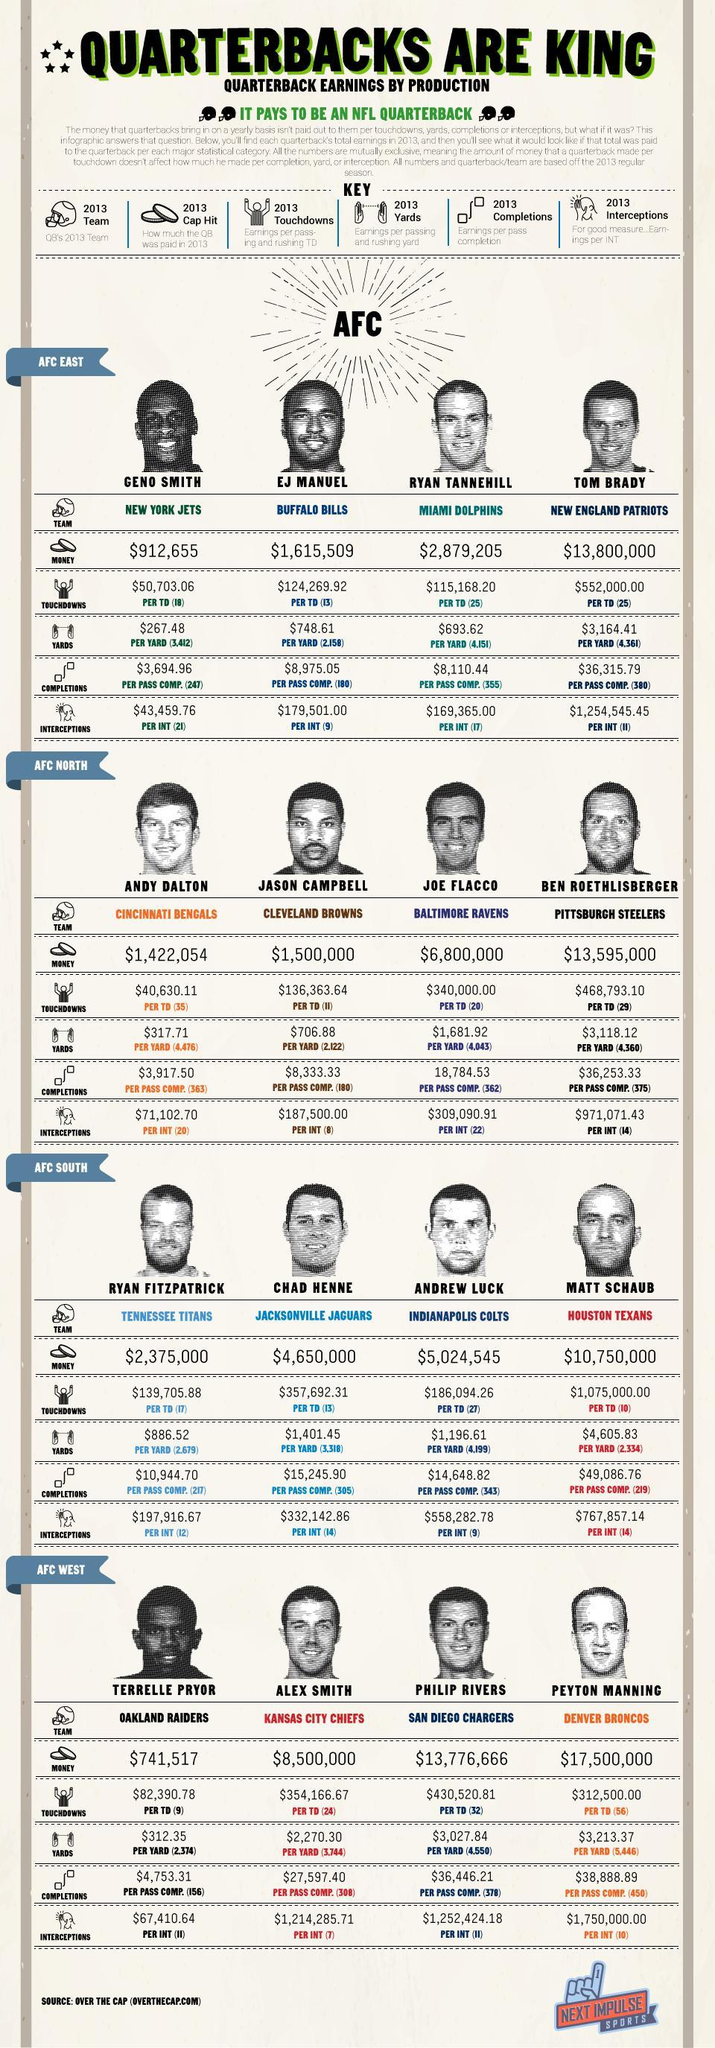How many teams are in the AFC South?
Answer the question with a short phrase. 4 Which AFC division does 'Buffalo Bills' play for in 2013 NFL? AFC EAST How many teams are in the AFC West? 4 What is the earnings per pass completions by EJ Manuel in 2013? $8,975.05 